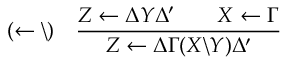<formula> <loc_0><loc_0><loc_500><loc_500>( \leftarrow \ ) \quad \frac { Z \leftarrow \Delta Y \Delta ^ { \prime } \quad X \leftarrow \Gamma } { Z \leftarrow \Delta \Gamma ( X \ Y ) \Delta ^ { \prime } }</formula> 